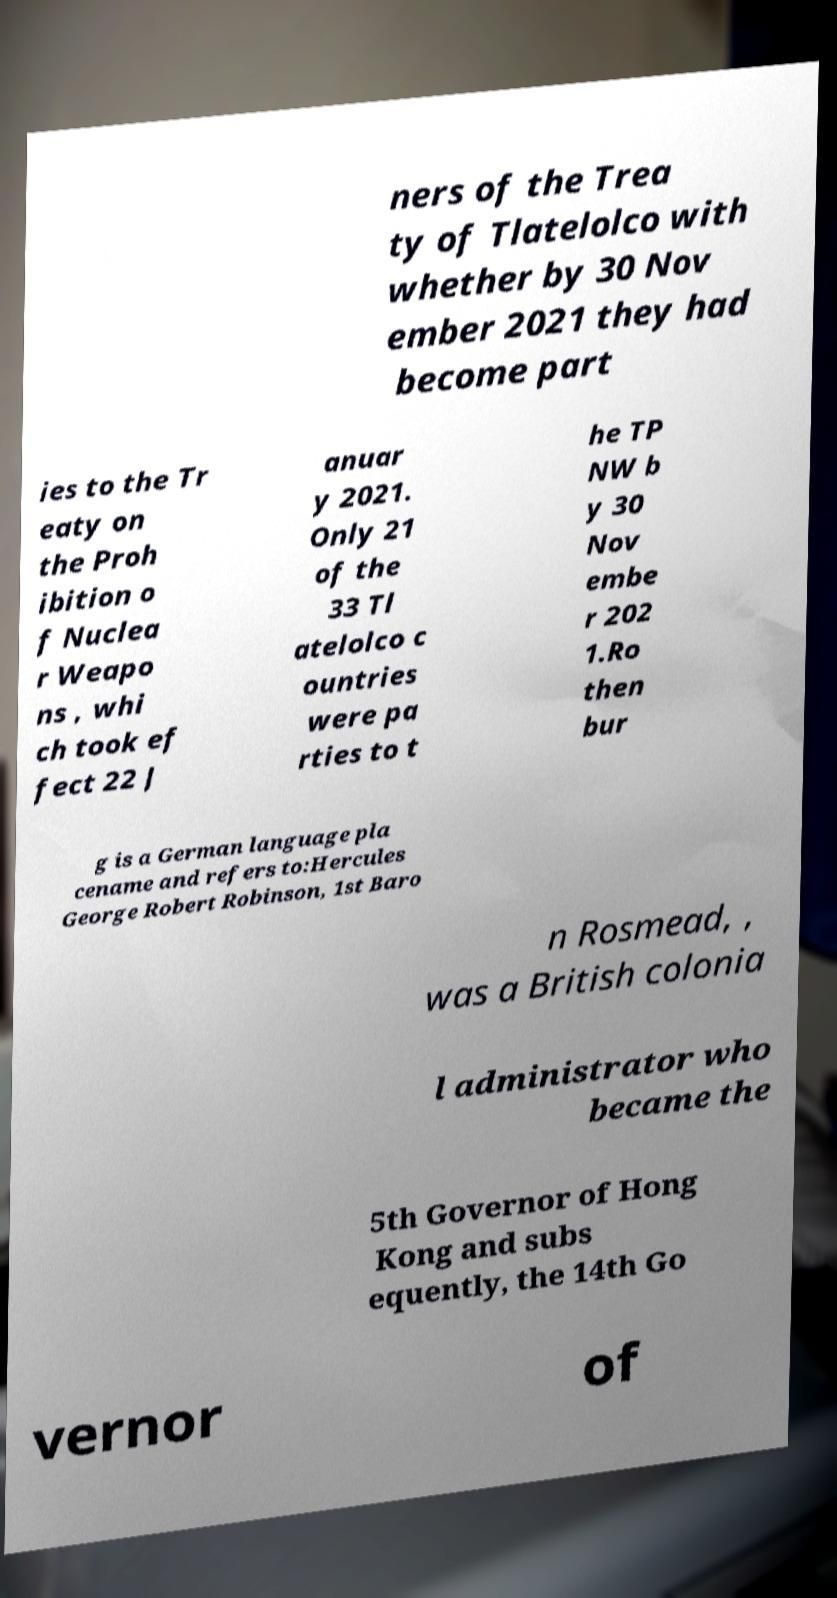For documentation purposes, I need the text within this image transcribed. Could you provide that? ners of the Trea ty of Tlatelolco with whether by 30 Nov ember 2021 they had become part ies to the Tr eaty on the Proh ibition o f Nuclea r Weapo ns , whi ch took ef fect 22 J anuar y 2021. Only 21 of the 33 Tl atelolco c ountries were pa rties to t he TP NW b y 30 Nov embe r 202 1.Ro then bur g is a German language pla cename and refers to:Hercules George Robert Robinson, 1st Baro n Rosmead, , was a British colonia l administrator who became the 5th Governor of Hong Kong and subs equently, the 14th Go vernor of 